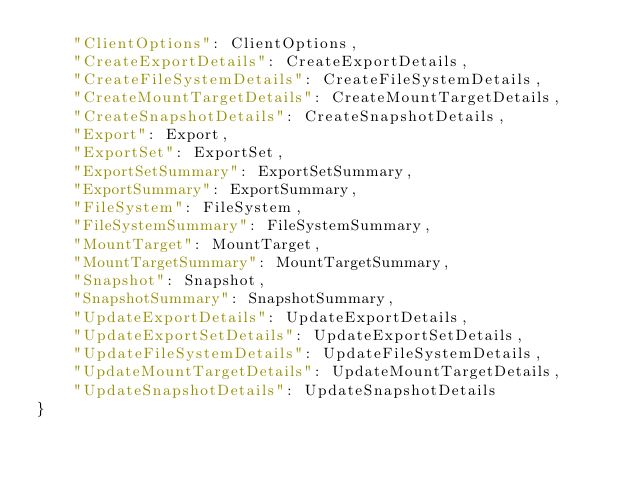<code> <loc_0><loc_0><loc_500><loc_500><_Python_>    "ClientOptions": ClientOptions,
    "CreateExportDetails": CreateExportDetails,
    "CreateFileSystemDetails": CreateFileSystemDetails,
    "CreateMountTargetDetails": CreateMountTargetDetails,
    "CreateSnapshotDetails": CreateSnapshotDetails,
    "Export": Export,
    "ExportSet": ExportSet,
    "ExportSetSummary": ExportSetSummary,
    "ExportSummary": ExportSummary,
    "FileSystem": FileSystem,
    "FileSystemSummary": FileSystemSummary,
    "MountTarget": MountTarget,
    "MountTargetSummary": MountTargetSummary,
    "Snapshot": Snapshot,
    "SnapshotSummary": SnapshotSummary,
    "UpdateExportDetails": UpdateExportDetails,
    "UpdateExportSetDetails": UpdateExportSetDetails,
    "UpdateFileSystemDetails": UpdateFileSystemDetails,
    "UpdateMountTargetDetails": UpdateMountTargetDetails,
    "UpdateSnapshotDetails": UpdateSnapshotDetails
}
</code> 